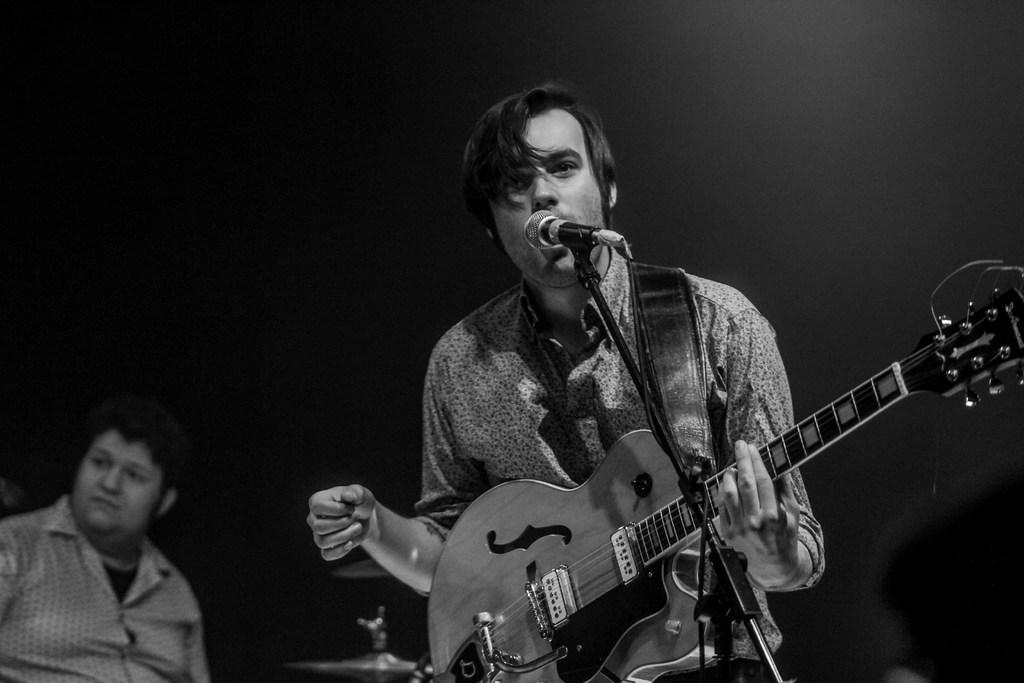What is the man in the image doing? The man is singing in the image. What is the man holding while singing? The man is holding a microphone. What instrument is the man playing? The man is playing a guitar. Are there any other people in the image? Yes, there is a second man in the image. What is the second man doing? The second man is playing drums. How does the man pull the neck of the guitar in the image? There is no indication in the image that the man is pulling the neck of the guitar. 